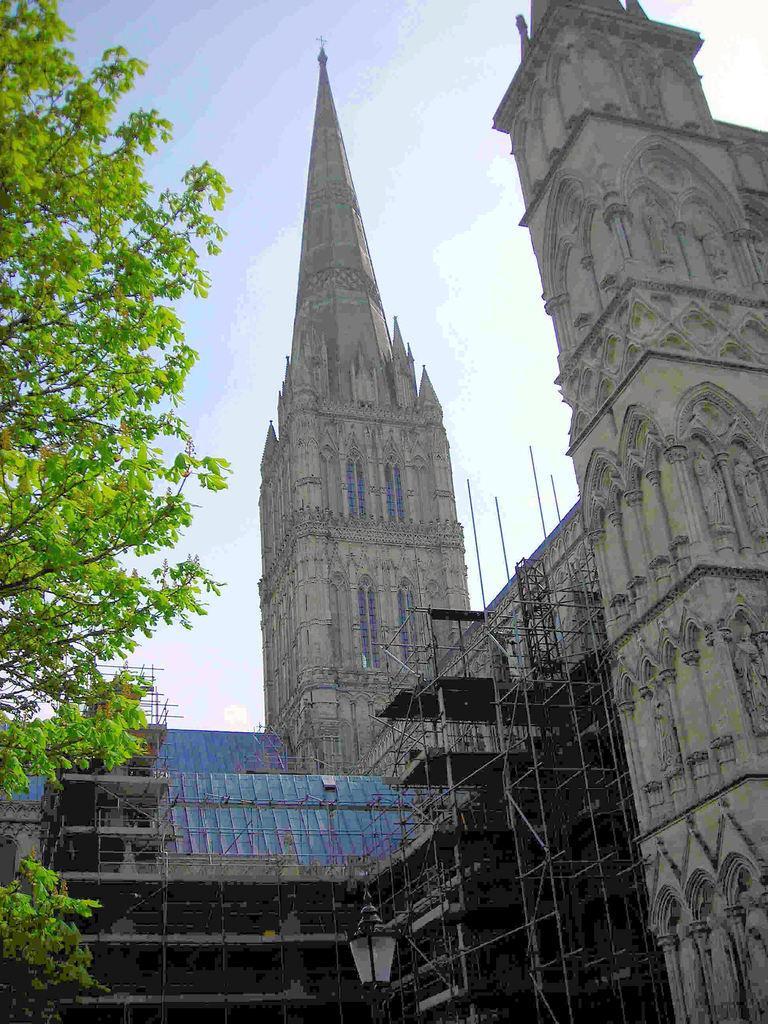How would you summarize this image in a sentence or two? In this picture there is a castle which is in grey in color and it is towards the right. Towards the left, there is a tree. On the top there is a sky with clouds. 